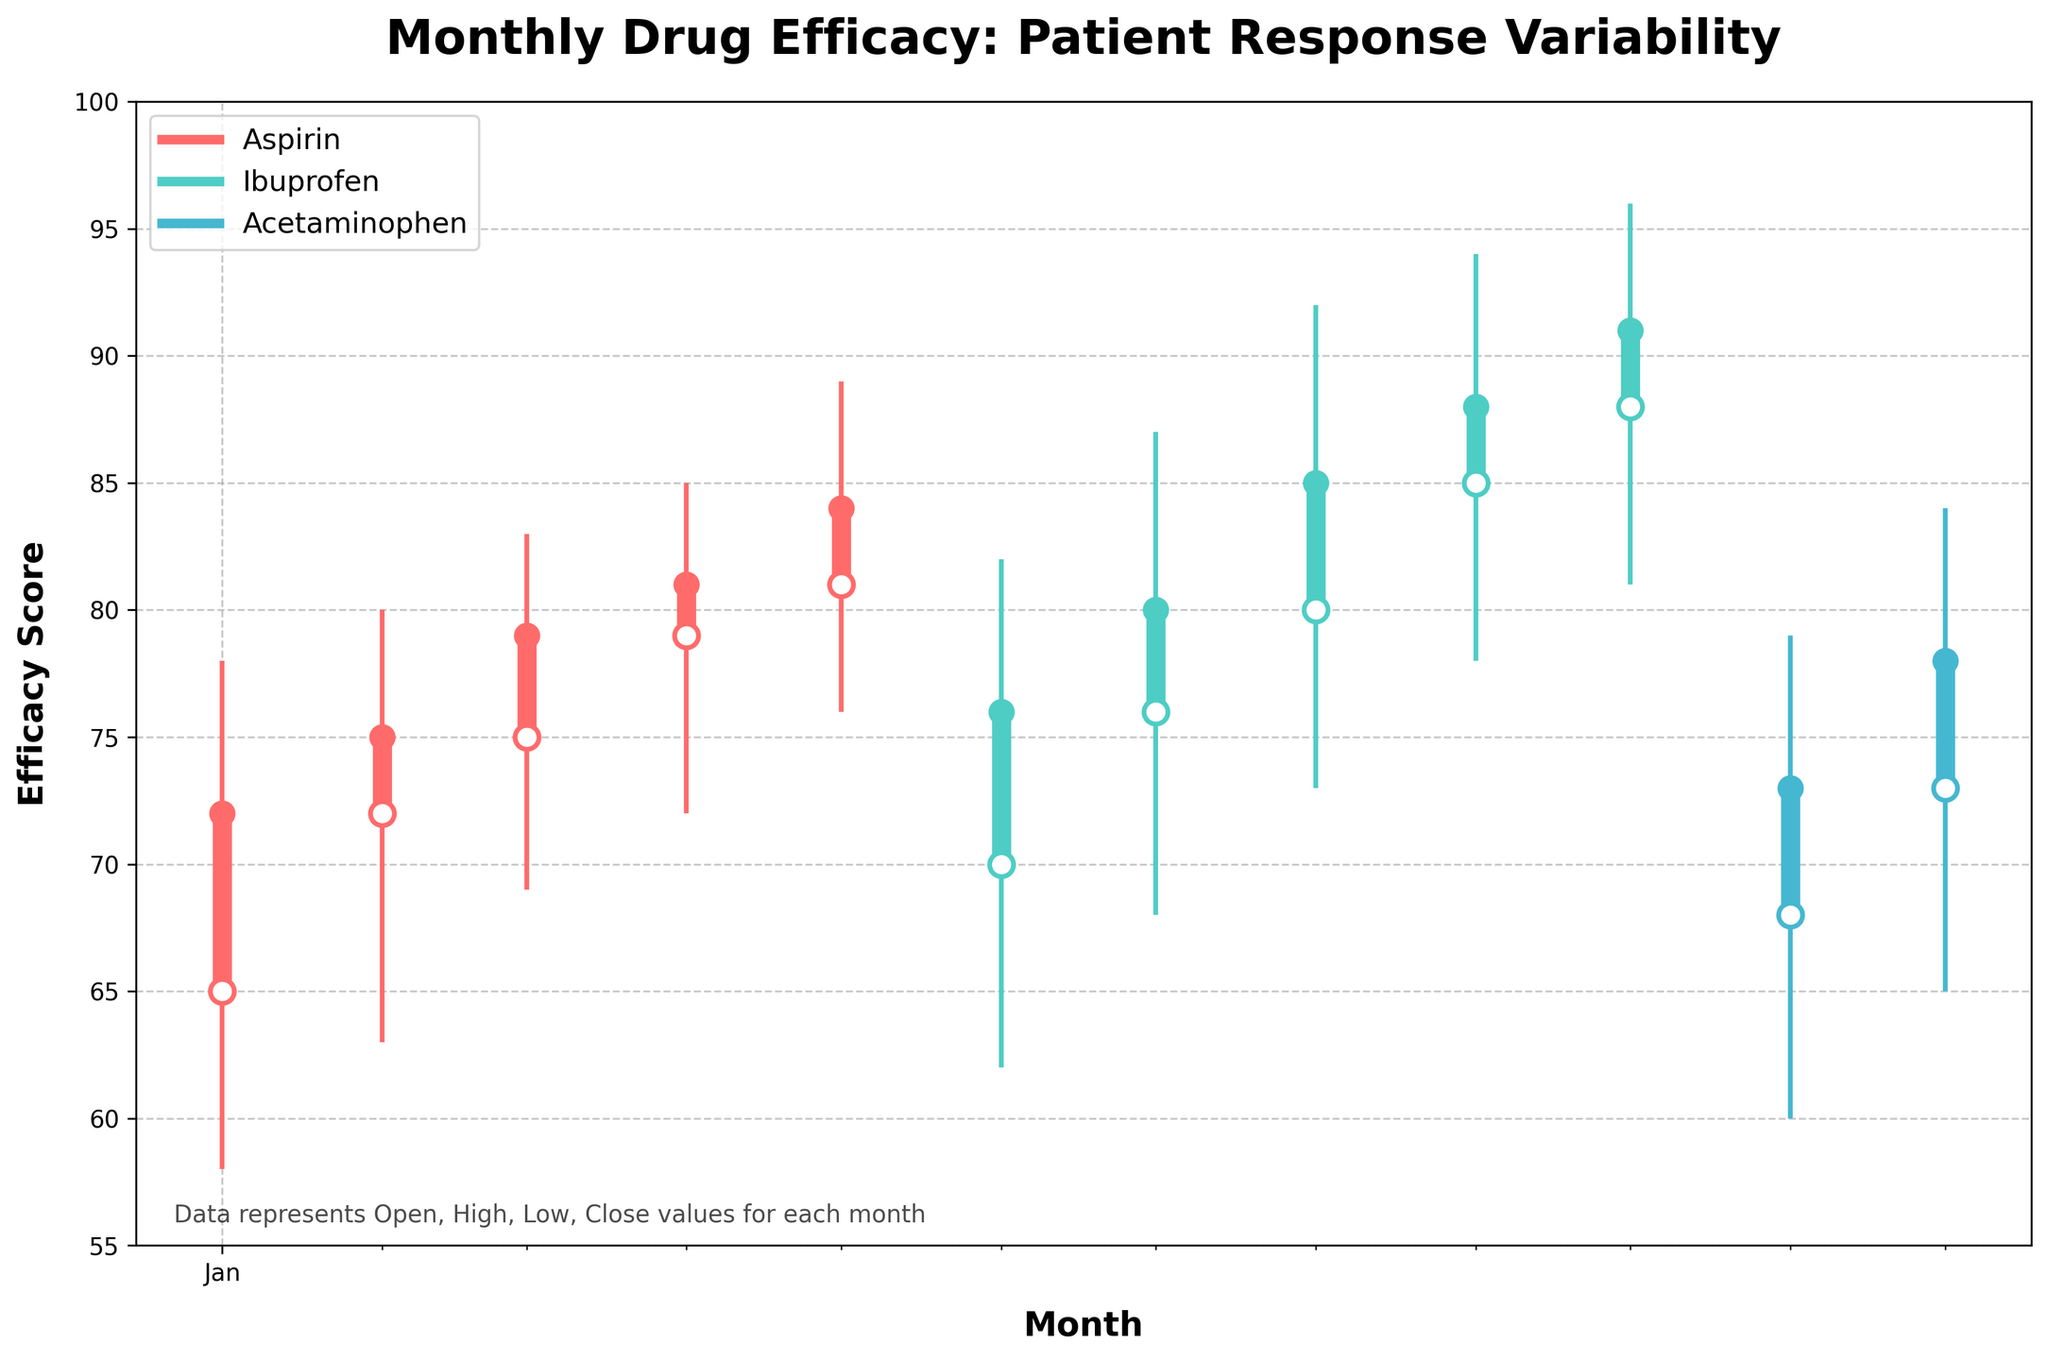How many data points are there in the figure? Count the number of months plotted on the x-axis for all the drugs.
Answer: 12 Which drug has the highest value in October? Look at the high value for each drug in October on the chart.
Answer: Ibuprofen In which month does Aspirin show the lowest efficacy score? Find the lowest (Low) value for Aspirin across the months.
Answer: January Compare the closing values of Ibuprofen for August and September. Which month has a higher close value? Check the close value for Ibuprofen in August and September and compare them.
Answer: September What is the range of efficacy scores for Acetaminophen in November? Find the difference between the high and low values for Acetaminophen in November.
Answer: 19 Which month shows the highest variability in patient response for any drug? Look for the month with the largest difference between high and low values across all drugs.
Answer: October (Ibuprofen) What is the average opening value for Ibuprofen over the months it was measured? Summing the opening values of Ibuprofen from June to October and dividing by the number of months. (70+76+80+85+88)/5
Answer: 79.8 Which drug shows the steepest increase in closing values over the months? Compare the slope of the closing values over time for each drug.
Answer: Aspirin What is the difference between the closing and opening values for Acetaminophen in December? Subtract the opening value from the closing value for Acetaminophen in December.
Answer: 5 Are there any months where the opening and closing values for any drug are the same? Check if any drug has an equal opening and closing value in any month.
Answer: No 